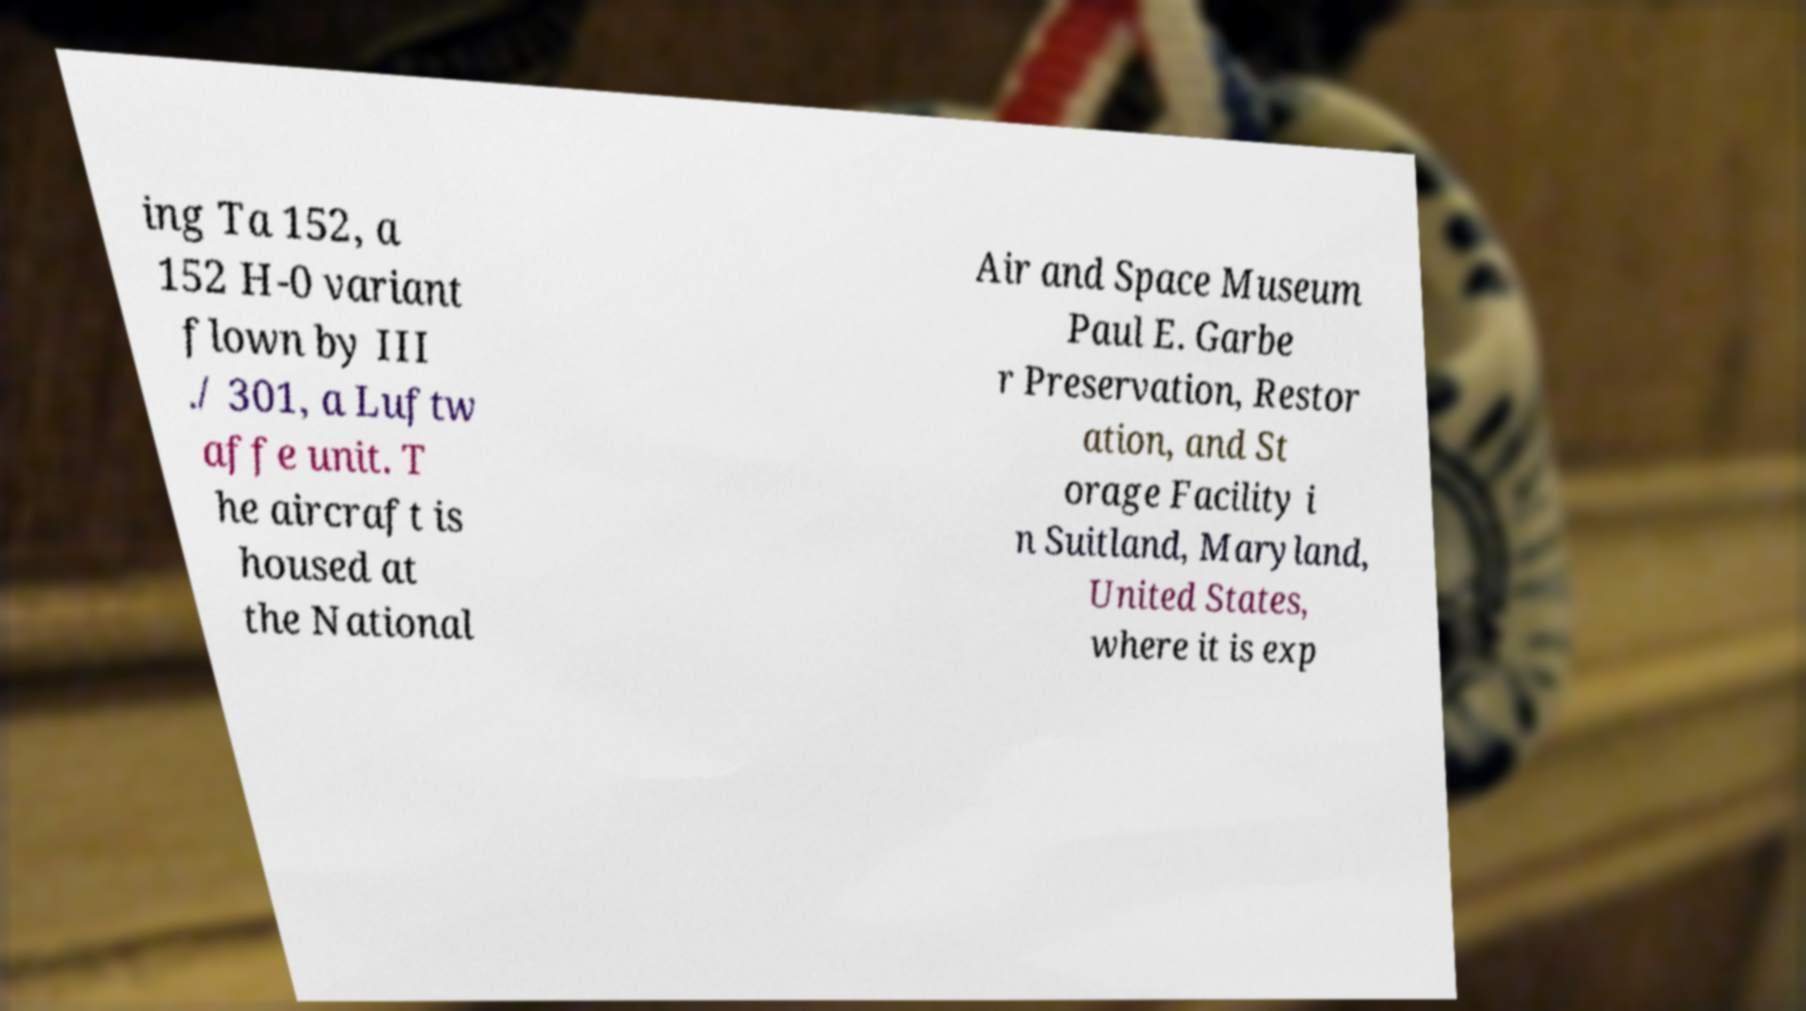What messages or text are displayed in this image? I need them in a readable, typed format. ing Ta 152, a 152 H-0 variant flown by III ./ 301, a Luftw affe unit. T he aircraft is housed at the National Air and Space Museum Paul E. Garbe r Preservation, Restor ation, and St orage Facility i n Suitland, Maryland, United States, where it is exp 